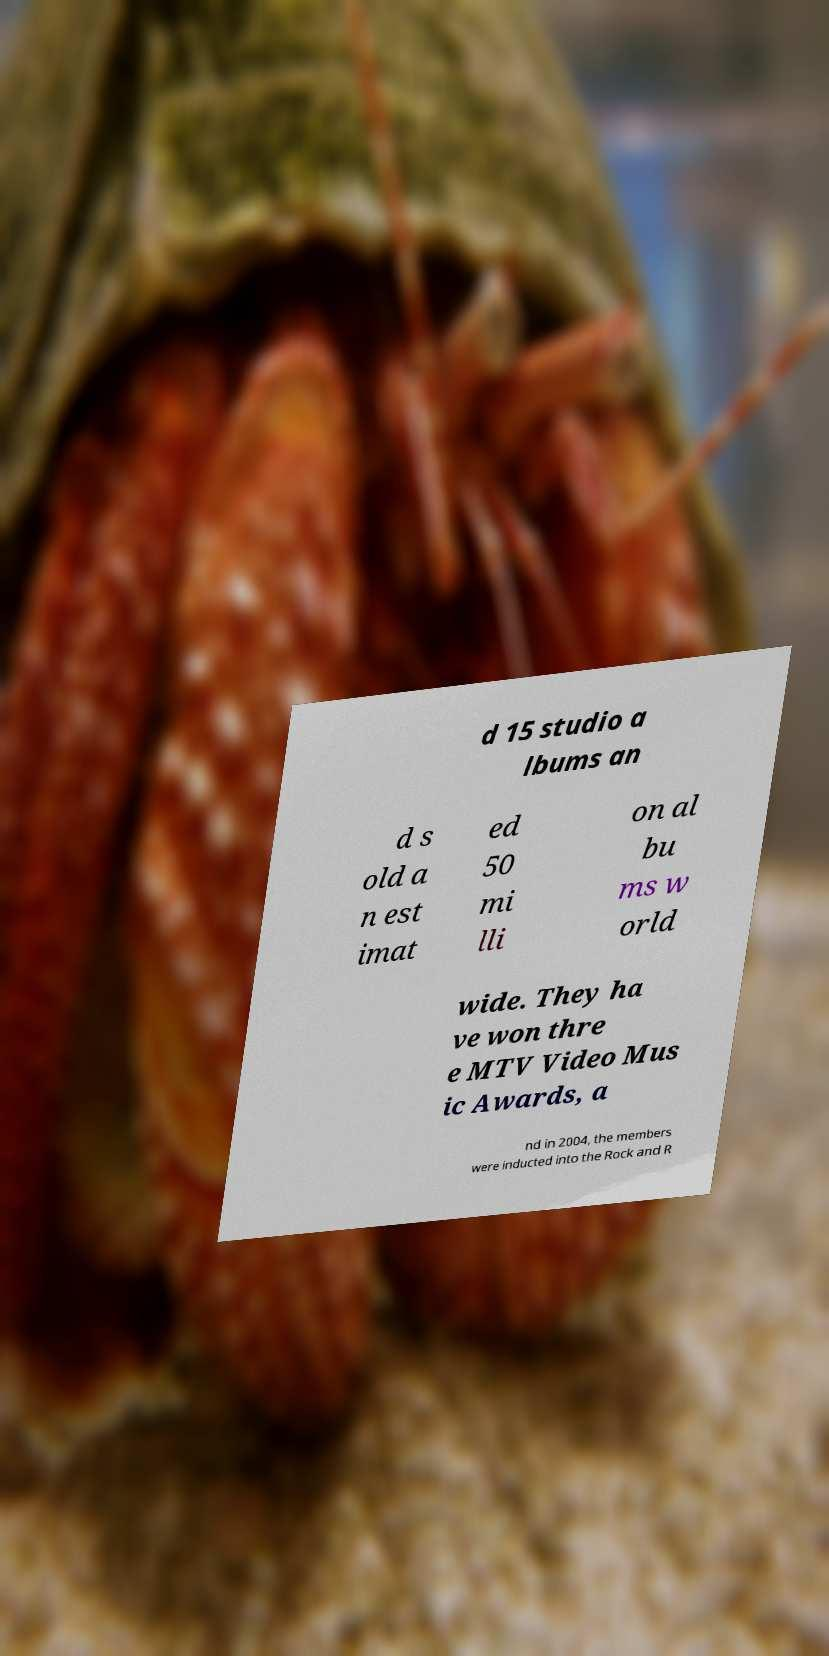Could you extract and type out the text from this image? d 15 studio a lbums an d s old a n est imat ed 50 mi lli on al bu ms w orld wide. They ha ve won thre e MTV Video Mus ic Awards, a nd in 2004, the members were inducted into the Rock and R 